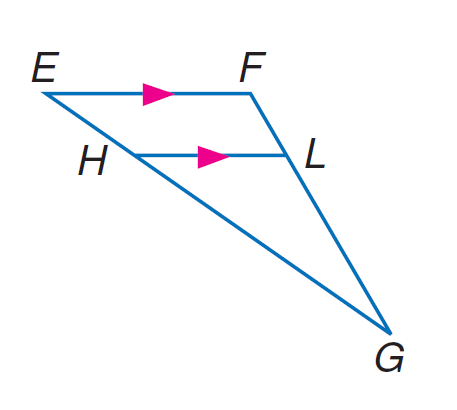Answer the mathemtical geometry problem and directly provide the correct option letter.
Question: In \triangle E F G, H L \parallel E F, E H = 9, H G = 21, and F L = 6. Find L G.
Choices: A: 12 B: 14 C: 15 D: 16 B 